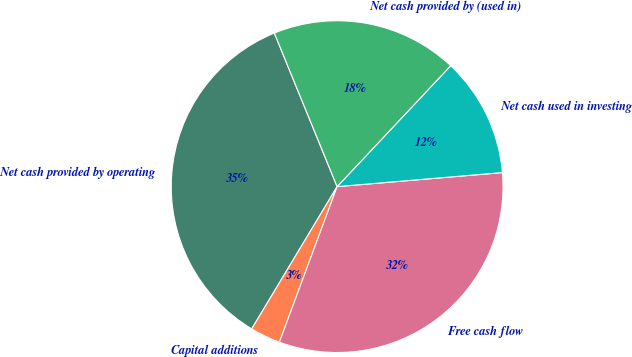<chart> <loc_0><loc_0><loc_500><loc_500><pie_chart><fcel>Net cash provided by operating<fcel>Capital additions<fcel>Free cash flow<fcel>Net cash used in investing<fcel>Net cash provided by (used in)<nl><fcel>35.22%<fcel>2.95%<fcel>32.01%<fcel>11.65%<fcel>18.18%<nl></chart> 